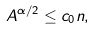Convert formula to latex. <formula><loc_0><loc_0><loc_500><loc_500>A ^ { \alpha / 2 } \leq c _ { 0 } n ,</formula> 